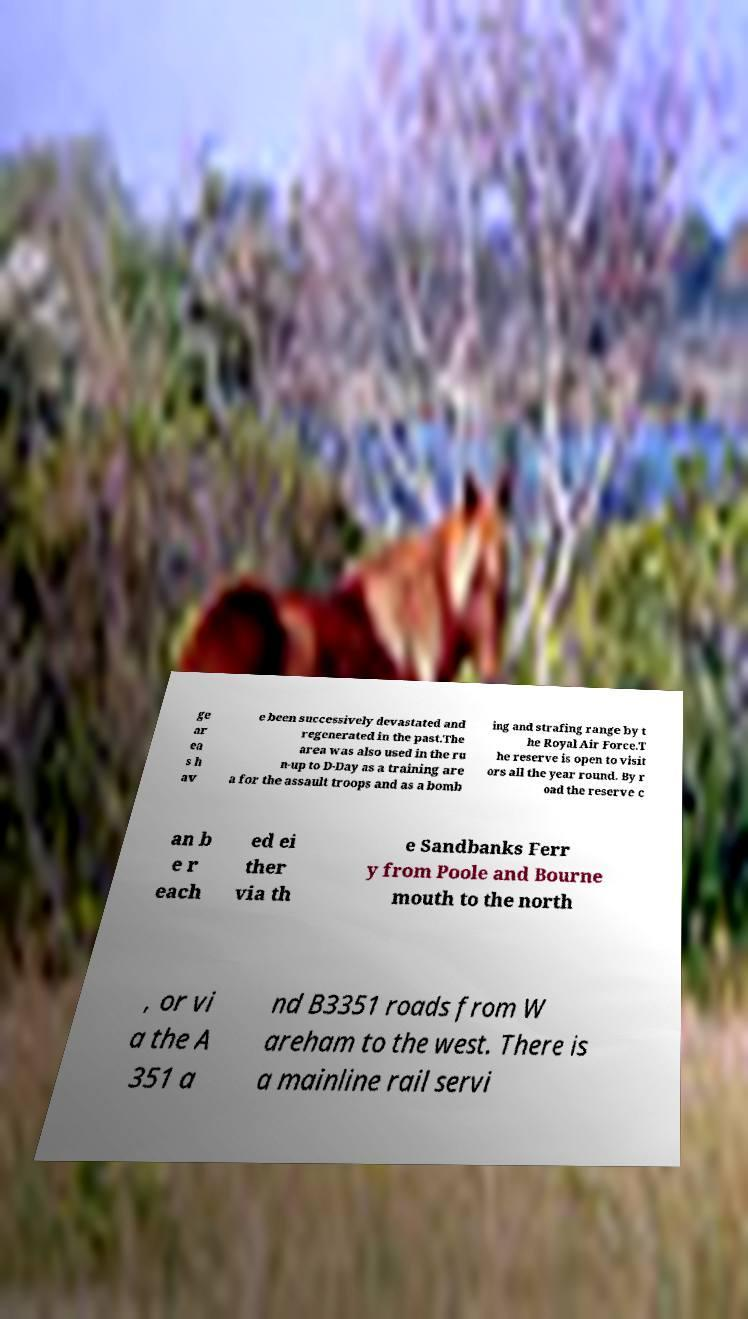Please read and relay the text visible in this image. What does it say? ge ar ea s h av e been successively devastated and regenerated in the past.The area was also used in the ru n-up to D-Day as a training are a for the assault troops and as a bomb ing and strafing range by t he Royal Air Force.T he reserve is open to visit ors all the year round. By r oad the reserve c an b e r each ed ei ther via th e Sandbanks Ferr y from Poole and Bourne mouth to the north , or vi a the A 351 a nd B3351 roads from W areham to the west. There is a mainline rail servi 